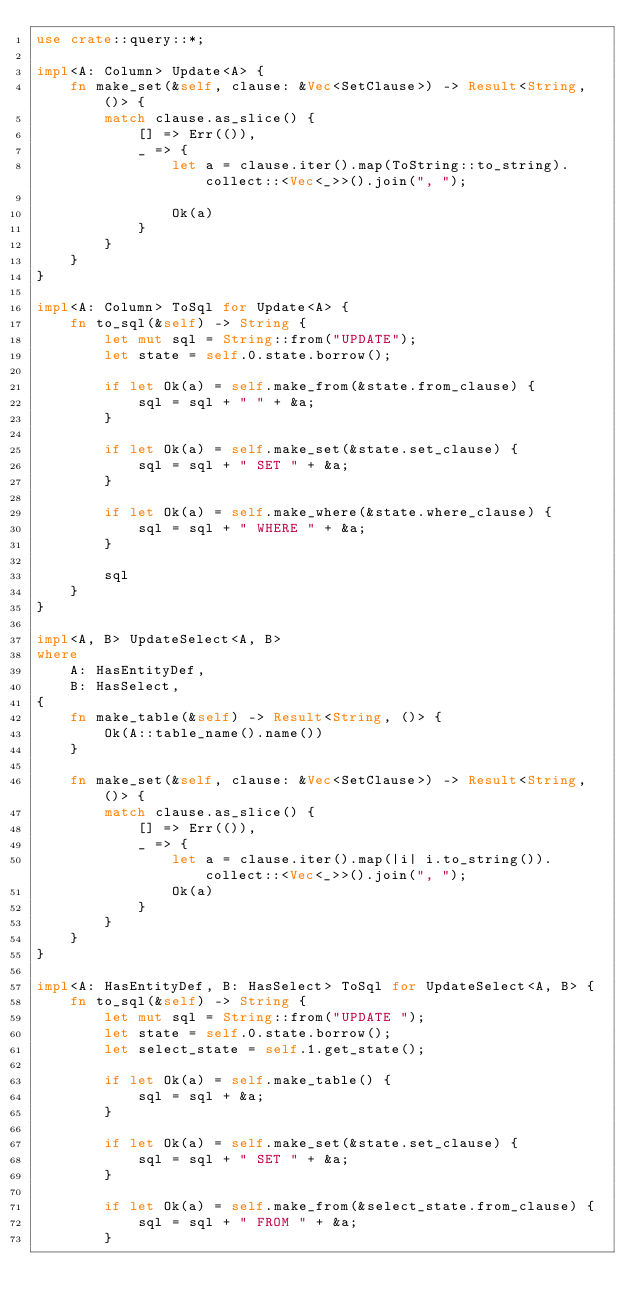<code> <loc_0><loc_0><loc_500><loc_500><_Rust_>use crate::query::*;

impl<A: Column> Update<A> {
    fn make_set(&self, clause: &Vec<SetClause>) -> Result<String, ()> {
        match clause.as_slice() {
            [] => Err(()),
            _ => {
                let a = clause.iter().map(ToString::to_string).collect::<Vec<_>>().join(", ");

                Ok(a)
            }
        }
    }
}

impl<A: Column> ToSql for Update<A> {
    fn to_sql(&self) -> String {
        let mut sql = String::from("UPDATE");
        let state = self.0.state.borrow();

        if let Ok(a) = self.make_from(&state.from_clause) {
            sql = sql + " " + &a;
        }

        if let Ok(a) = self.make_set(&state.set_clause) {
            sql = sql + " SET " + &a;
        }
        
        if let Ok(a) = self.make_where(&state.where_clause) {
            sql = sql + " WHERE " + &a;
        }

        sql
    }
}

impl<A, B> UpdateSelect<A, B>
where
    A: HasEntityDef,
    B: HasSelect,
{
    fn make_table(&self) -> Result<String, ()> {
        Ok(A::table_name().name())
    }

    fn make_set(&self, clause: &Vec<SetClause>) -> Result<String, ()> {
        match clause.as_slice() {
            [] => Err(()),
            _ => {
                let a = clause.iter().map(|i| i.to_string()).collect::<Vec<_>>().join(", ");
                Ok(a)
            }
        }
    }
}

impl<A: HasEntityDef, B: HasSelect> ToSql for UpdateSelect<A, B> {
    fn to_sql(&self) -> String {
        let mut sql = String::from("UPDATE ");
        let state = self.0.state.borrow();
        let select_state = self.1.get_state();

        if let Ok(a) = self.make_table() {
            sql = sql + &a;
        }

        if let Ok(a) = self.make_set(&state.set_clause) {
            sql = sql + " SET " + &a;
        }

        if let Ok(a) = self.make_from(&select_state.from_clause) {
            sql = sql + " FROM " + &a;
        }
</code> 